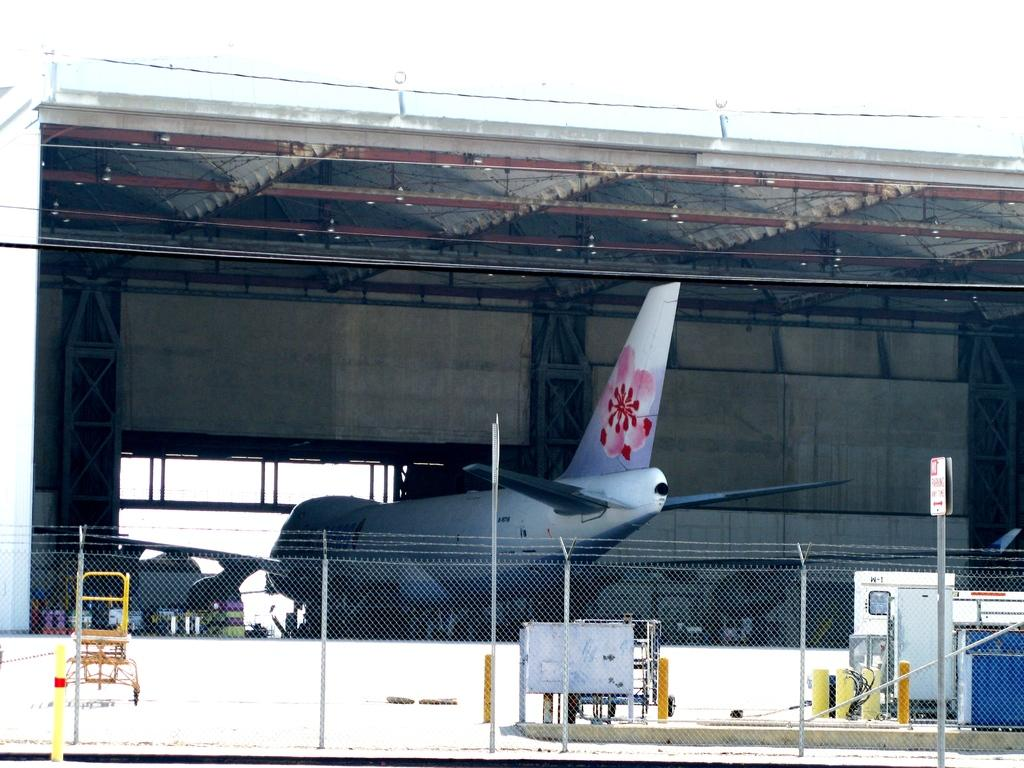What is the main subject of the image? The main subject of the image is an aeroplane. What other objects can be seen in the image? There is a fence, poles, a board, and a shed visible in the image. What is the background of the image? The sky is visible in the background of the image. What type of silver curve can be seen on the aeroplane in the image? There is no silver curve present on the aeroplane in the image. What are the people in the image talking about? There are no people present in the image, so it is not possible to determine what they might be talking about. 